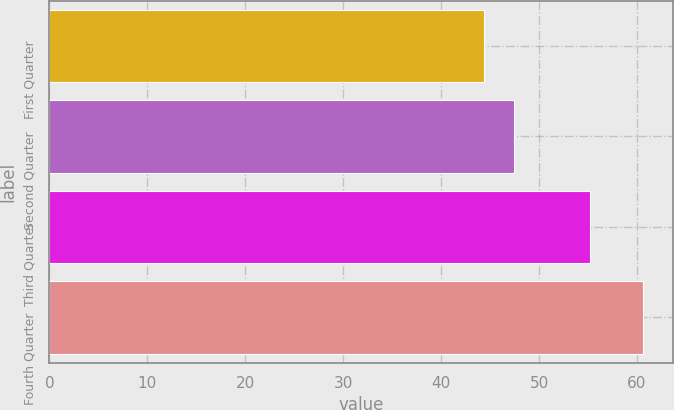<chart> <loc_0><loc_0><loc_500><loc_500><bar_chart><fcel>First Quarter<fcel>Second Quarter<fcel>Third Quarter<fcel>Fourth Quarter<nl><fcel>44.36<fcel>47.41<fcel>55.25<fcel>60.64<nl></chart> 